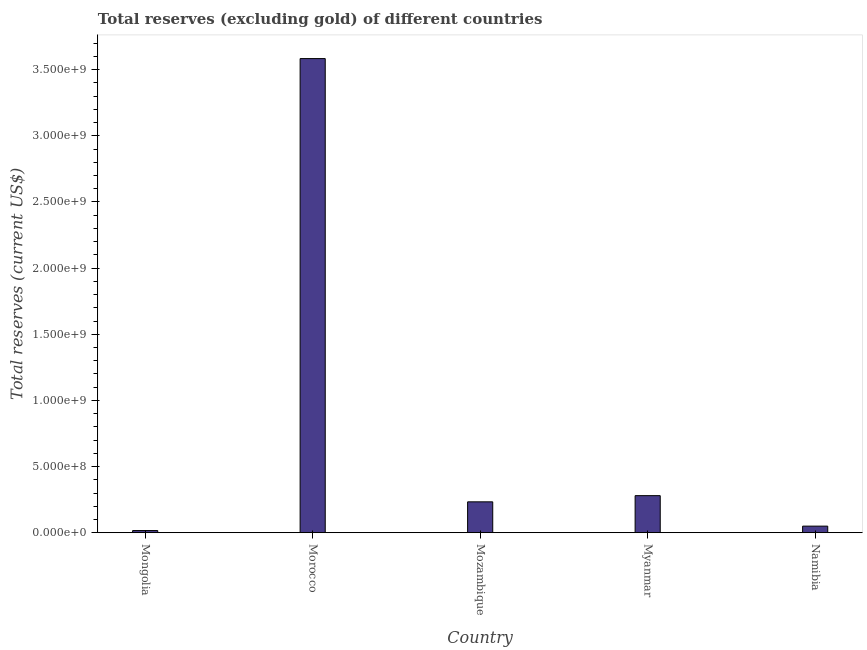Does the graph contain any zero values?
Give a very brief answer. No. What is the title of the graph?
Your answer should be compact. Total reserves (excluding gold) of different countries. What is the label or title of the Y-axis?
Provide a short and direct response. Total reserves (current US$). What is the total reserves (excluding gold) in Morocco?
Provide a succinct answer. 3.58e+09. Across all countries, what is the maximum total reserves (excluding gold)?
Make the answer very short. 3.58e+09. Across all countries, what is the minimum total reserves (excluding gold)?
Your answer should be compact. 1.64e+07. In which country was the total reserves (excluding gold) maximum?
Your answer should be very brief. Morocco. In which country was the total reserves (excluding gold) minimum?
Your answer should be compact. Mongolia. What is the sum of the total reserves (excluding gold)?
Make the answer very short. 4.16e+09. What is the difference between the total reserves (excluding gold) in Mongolia and Morocco?
Offer a terse response. -3.57e+09. What is the average total reserves (excluding gold) per country?
Offer a very short reply. 8.33e+08. What is the median total reserves (excluding gold)?
Your answer should be very brief. 2.33e+08. What is the ratio of the total reserves (excluding gold) in Mozambique to that in Namibia?
Keep it short and to the point. 4.69. Is the difference between the total reserves (excluding gold) in Mozambique and Namibia greater than the difference between any two countries?
Make the answer very short. No. What is the difference between the highest and the second highest total reserves (excluding gold)?
Provide a short and direct response. 3.30e+09. What is the difference between the highest and the lowest total reserves (excluding gold)?
Offer a terse response. 3.57e+09. How many bars are there?
Your answer should be very brief. 5. Are the values on the major ticks of Y-axis written in scientific E-notation?
Offer a very short reply. Yes. What is the Total reserves (current US$) of Mongolia?
Offer a terse response. 1.64e+07. What is the Total reserves (current US$) of Morocco?
Your answer should be very brief. 3.58e+09. What is the Total reserves (current US$) in Mozambique?
Your answer should be compact. 2.33e+08. What is the Total reserves (current US$) of Myanmar?
Offer a terse response. 2.80e+08. What is the Total reserves (current US$) of Namibia?
Your answer should be very brief. 4.97e+07. What is the difference between the Total reserves (current US$) in Mongolia and Morocco?
Make the answer very short. -3.57e+09. What is the difference between the Total reserves (current US$) in Mongolia and Mozambique?
Offer a very short reply. -2.17e+08. What is the difference between the Total reserves (current US$) in Mongolia and Myanmar?
Offer a very short reply. -2.64e+08. What is the difference between the Total reserves (current US$) in Mongolia and Namibia?
Offer a very short reply. -3.34e+07. What is the difference between the Total reserves (current US$) in Morocco and Mozambique?
Make the answer very short. 3.35e+09. What is the difference between the Total reserves (current US$) in Morocco and Myanmar?
Provide a short and direct response. 3.30e+09. What is the difference between the Total reserves (current US$) in Morocco and Namibia?
Offer a very short reply. 3.53e+09. What is the difference between the Total reserves (current US$) in Mozambique and Myanmar?
Give a very brief answer. -4.67e+07. What is the difference between the Total reserves (current US$) in Mozambique and Namibia?
Offer a terse response. 1.84e+08. What is the difference between the Total reserves (current US$) in Myanmar and Namibia?
Make the answer very short. 2.30e+08. What is the ratio of the Total reserves (current US$) in Mongolia to that in Morocco?
Offer a very short reply. 0.01. What is the ratio of the Total reserves (current US$) in Mongolia to that in Mozambique?
Provide a succinct answer. 0.07. What is the ratio of the Total reserves (current US$) in Mongolia to that in Myanmar?
Your answer should be very brief. 0.06. What is the ratio of the Total reserves (current US$) in Mongolia to that in Namibia?
Your answer should be compact. 0.33. What is the ratio of the Total reserves (current US$) in Morocco to that in Mozambique?
Your answer should be very brief. 15.36. What is the ratio of the Total reserves (current US$) in Morocco to that in Myanmar?
Your answer should be compact. 12.79. What is the ratio of the Total reserves (current US$) in Morocco to that in Namibia?
Keep it short and to the point. 72.09. What is the ratio of the Total reserves (current US$) in Mozambique to that in Myanmar?
Ensure brevity in your answer.  0.83. What is the ratio of the Total reserves (current US$) in Mozambique to that in Namibia?
Provide a short and direct response. 4.69. What is the ratio of the Total reserves (current US$) in Myanmar to that in Namibia?
Offer a very short reply. 5.63. 